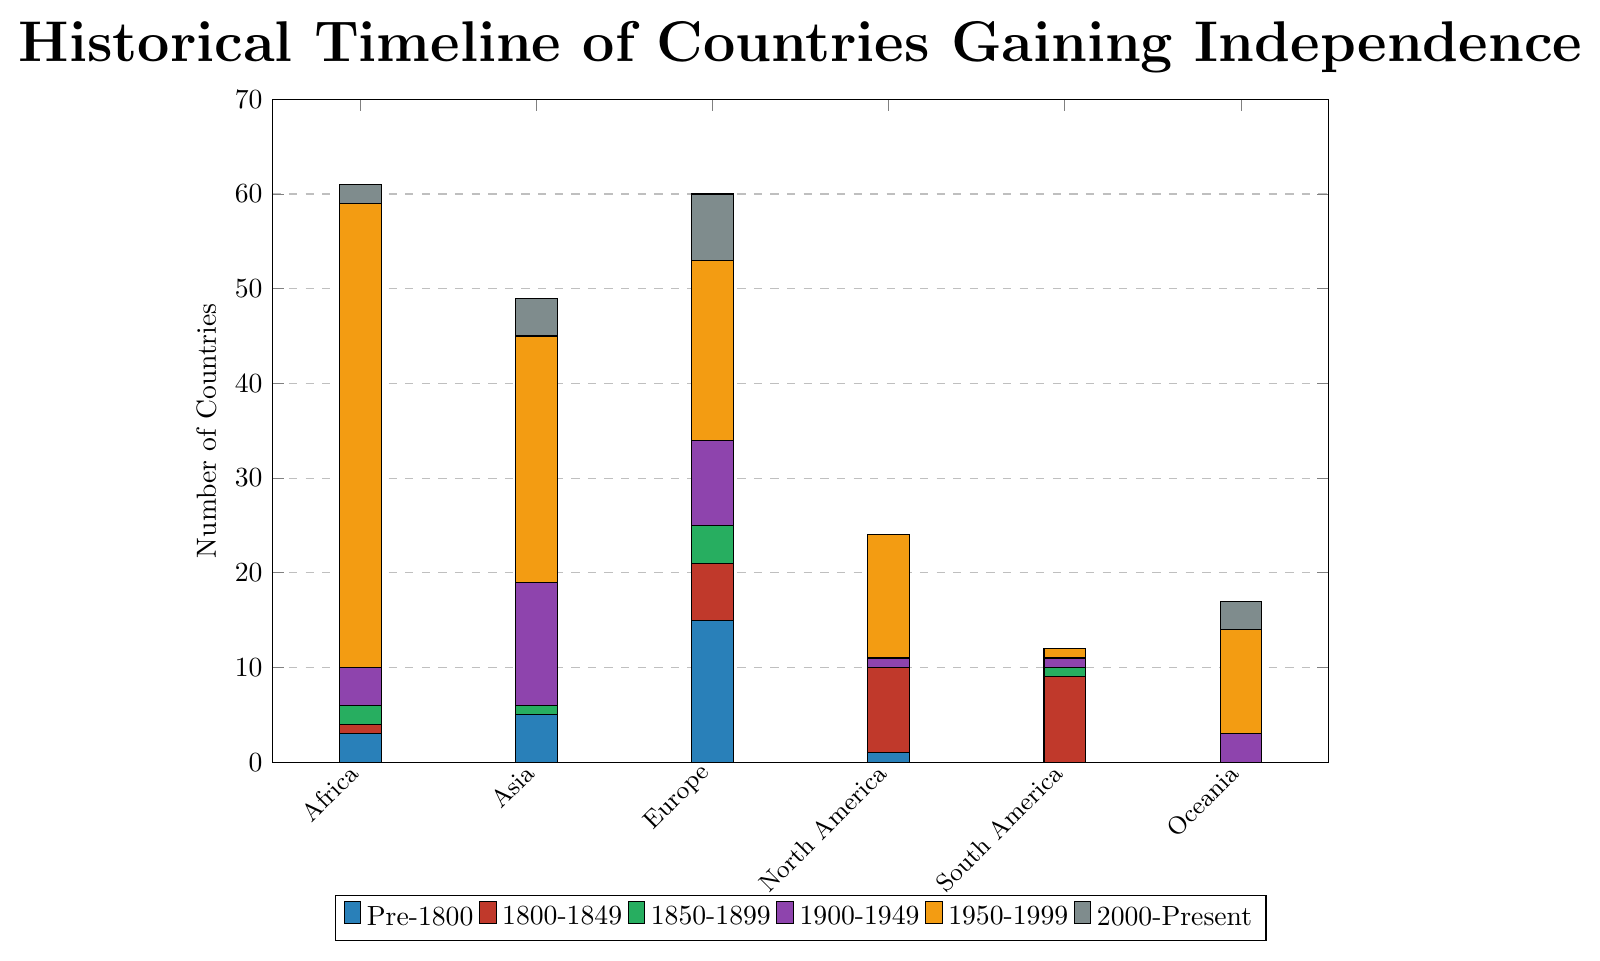How many countries in Africa gained independence between 1950-1999? The height of the orange bar for Africa represents the number of countries that gained independence between 1950-1999.
Answer: 49 Which continent had the most countries gaining independence in the period Pre-1800? By comparing the heights of the green bars, Europe has the tallest one for the Pre-1800 period.
Answer: Europe What is the total number of countries in Oceania that gained independence from 1800 to the present? Sum up the heights of the bars from 1800-1849, 1850-1899, 1900-1949, 1950-1999, and 2000-Present for Oceania. Calculation: 0 + 0 + 3 + 11 + 3 = 17
Answer: 17 How many more countries gained independence in Asia compared to Africa in the 1900-1949 period? Compare the heights of the purple bars for Asia and Africa. Calculation: 13 (Asia) - 4 (Africa) = 9
Answer: 9 Which continent did not have any countries gain independence between 1800-1849? Find the bars colored in red and check which continent has a value of 0.
Answer: Asia, South America, and Oceania Which period saw the highest number of countries gaining independence in Europe? Find the highest bar for Europe and see which period it corresponds to.
Answer: 1950-1999 What is the average number of countries gaining independence across all continents in the period 2000-Present? Sum up the heights of the bars for 2000-Present for all continents and then divide by the number of continents. Calculation: (2 + 4 + 7 + 0 + 0 + 3)/6 = 16/6 ≈ 2.67
Answer: ~2.67 Are there any continents where no countries gained independence before 1800? Look at the green bars for each continent and check if any have a value of 0.
Answer: South America, Oceania How does the number of countries gaining independence in North America between 1800-1849 compare to that in South America in the same period? Compare the heights of the red bars for North America and South America in the 1800-1849 period.
Answer: North America has the same number as South America (both 9) Which two continents have the same number of countries gaining independence in the 1850-1899 period? Compare the heights of the blue bars for all continents in the 1850-1899 period and find any that are equal.
Answer: Africa and South America (both 1) 